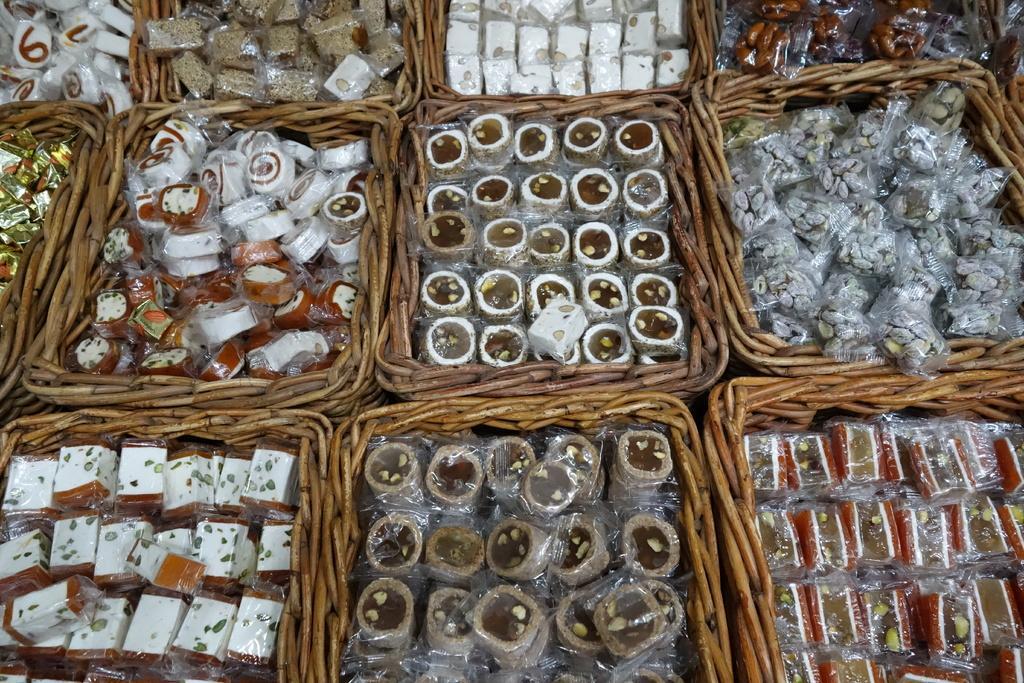How would you summarize this image in a sentence or two? In this image we can see sweets placed in a baskets. 